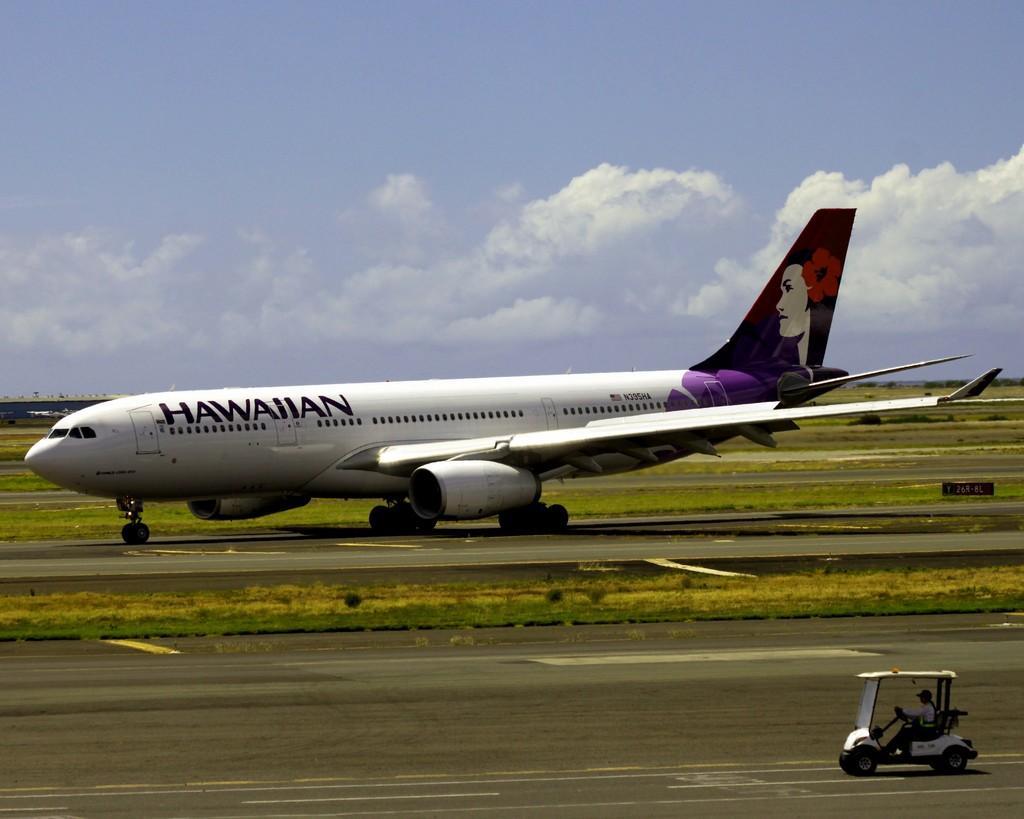Describe this image in one or two sentences. In this image I can see the person riding the vehicle and I can also see an aircraft. In the background the sky is in blue and white color. 